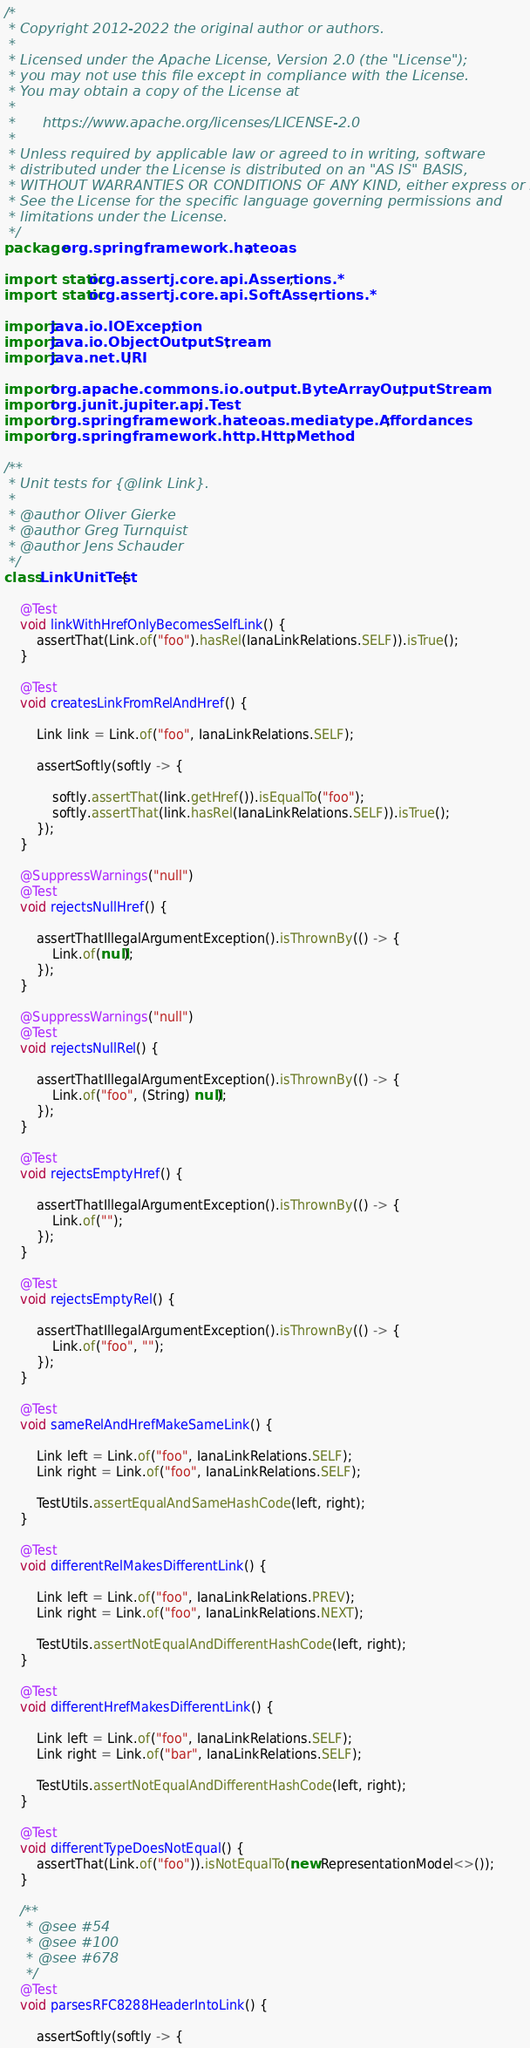Convert code to text. <code><loc_0><loc_0><loc_500><loc_500><_Java_>/*
 * Copyright 2012-2022 the original author or authors.
 *
 * Licensed under the Apache License, Version 2.0 (the "License");
 * you may not use this file except in compliance with the License.
 * You may obtain a copy of the License at
 *
 *      https://www.apache.org/licenses/LICENSE-2.0
 *
 * Unless required by applicable law or agreed to in writing, software
 * distributed under the License is distributed on an "AS IS" BASIS,
 * WITHOUT WARRANTIES OR CONDITIONS OF ANY KIND, either express or implied.
 * See the License for the specific language governing permissions and
 * limitations under the License.
 */
package org.springframework.hateoas;

import static org.assertj.core.api.Assertions.*;
import static org.assertj.core.api.SoftAssertions.*;

import java.io.IOException;
import java.io.ObjectOutputStream;
import java.net.URI;

import org.apache.commons.io.output.ByteArrayOutputStream;
import org.junit.jupiter.api.Test;
import org.springframework.hateoas.mediatype.Affordances;
import org.springframework.http.HttpMethod;

/**
 * Unit tests for {@link Link}.
 *
 * @author Oliver Gierke
 * @author Greg Turnquist
 * @author Jens Schauder
 */
class LinkUnitTest {

	@Test
	void linkWithHrefOnlyBecomesSelfLink() {
		assertThat(Link.of("foo").hasRel(IanaLinkRelations.SELF)).isTrue();
	}

	@Test
	void createsLinkFromRelAndHref() {

		Link link = Link.of("foo", IanaLinkRelations.SELF);

		assertSoftly(softly -> {

			softly.assertThat(link.getHref()).isEqualTo("foo");
			softly.assertThat(link.hasRel(IanaLinkRelations.SELF)).isTrue();
		});
	}

	@SuppressWarnings("null")
	@Test
	void rejectsNullHref() {

		assertThatIllegalArgumentException().isThrownBy(() -> {
			Link.of(null);
		});
	}

	@SuppressWarnings("null")
	@Test
	void rejectsNullRel() {

		assertThatIllegalArgumentException().isThrownBy(() -> {
			Link.of("foo", (String) null);
		});
	}

	@Test
	void rejectsEmptyHref() {

		assertThatIllegalArgumentException().isThrownBy(() -> {
			Link.of("");
		});
	}

	@Test
	void rejectsEmptyRel() {

		assertThatIllegalArgumentException().isThrownBy(() -> {
			Link.of("foo", "");
		});
	}

	@Test
	void sameRelAndHrefMakeSameLink() {

		Link left = Link.of("foo", IanaLinkRelations.SELF);
		Link right = Link.of("foo", IanaLinkRelations.SELF);

		TestUtils.assertEqualAndSameHashCode(left, right);
	}

	@Test
	void differentRelMakesDifferentLink() {

		Link left = Link.of("foo", IanaLinkRelations.PREV);
		Link right = Link.of("foo", IanaLinkRelations.NEXT);

		TestUtils.assertNotEqualAndDifferentHashCode(left, right);
	}

	@Test
	void differentHrefMakesDifferentLink() {

		Link left = Link.of("foo", IanaLinkRelations.SELF);
		Link right = Link.of("bar", IanaLinkRelations.SELF);

		TestUtils.assertNotEqualAndDifferentHashCode(left, right);
	}

	@Test
	void differentTypeDoesNotEqual() {
		assertThat(Link.of("foo")).isNotEqualTo(new RepresentationModel<>());
	}

	/**
	 * @see #54
	 * @see #100
	 * @see #678
	 */
	@Test
	void parsesRFC8288HeaderIntoLink() {

		assertSoftly(softly -> {
</code> 